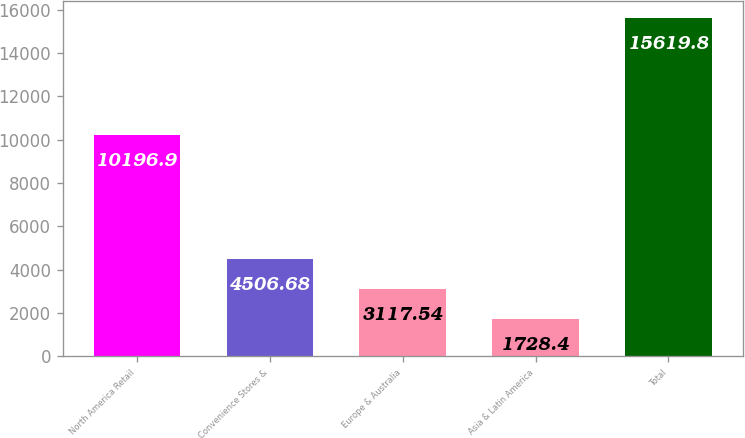Convert chart to OTSL. <chart><loc_0><loc_0><loc_500><loc_500><bar_chart><fcel>North America Retail<fcel>Convenience Stores &<fcel>Europe & Australia<fcel>Asia & Latin America<fcel>Total<nl><fcel>10196.9<fcel>4506.68<fcel>3117.54<fcel>1728.4<fcel>15619.8<nl></chart> 